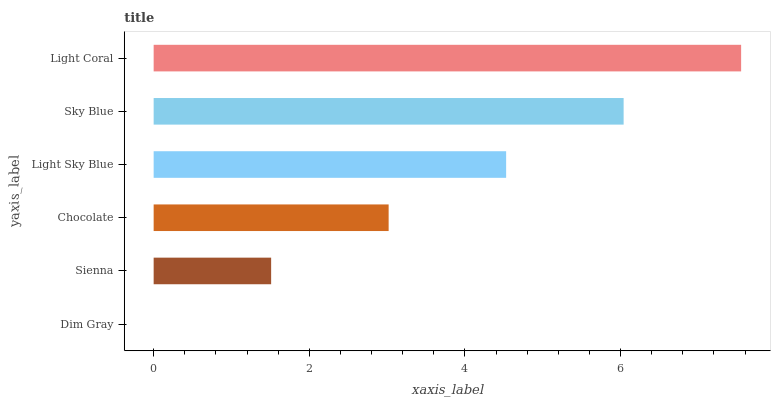Is Dim Gray the minimum?
Answer yes or no. Yes. Is Light Coral the maximum?
Answer yes or no. Yes. Is Sienna the minimum?
Answer yes or no. No. Is Sienna the maximum?
Answer yes or no. No. Is Sienna greater than Dim Gray?
Answer yes or no. Yes. Is Dim Gray less than Sienna?
Answer yes or no. Yes. Is Dim Gray greater than Sienna?
Answer yes or no. No. Is Sienna less than Dim Gray?
Answer yes or no. No. Is Light Sky Blue the high median?
Answer yes or no. Yes. Is Chocolate the low median?
Answer yes or no. Yes. Is Light Coral the high median?
Answer yes or no. No. Is Sky Blue the low median?
Answer yes or no. No. 